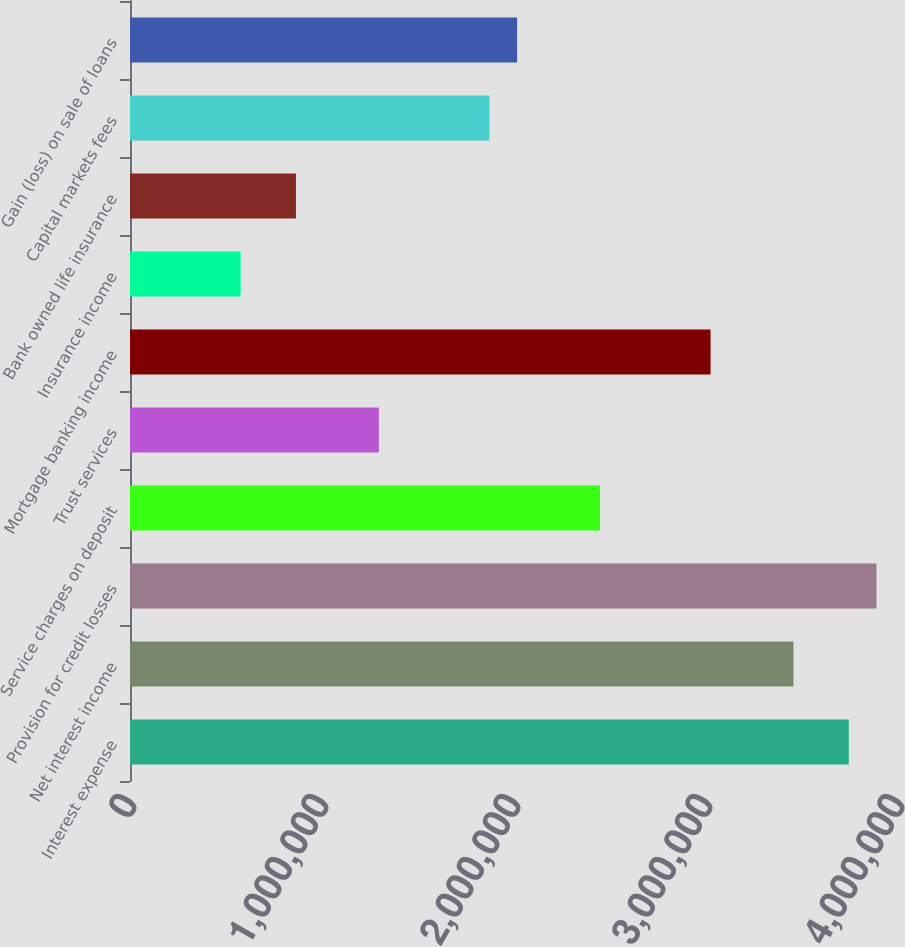Convert chart to OTSL. <chart><loc_0><loc_0><loc_500><loc_500><bar_chart><fcel>Interest expense<fcel>Net interest income<fcel>Provision for credit losses<fcel>Service charges on deposit<fcel>Trust services<fcel>Mortgage banking income<fcel>Insurance income<fcel>Bank owned life insurance<fcel>Capital markets fees<fcel>Gain (loss) on sale of loans<nl><fcel>3.74369e+06<fcel>3.45574e+06<fcel>3.88766e+06<fcel>2.44793e+06<fcel>1.29615e+06<fcel>3.02383e+06<fcel>576287<fcel>864232<fcel>1.87204e+06<fcel>2.01602e+06<nl></chart> 